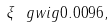Convert formula to latex. <formula><loc_0><loc_0><loc_500><loc_500>\xi \ g w i g 0 . 0 0 9 6 ,</formula> 